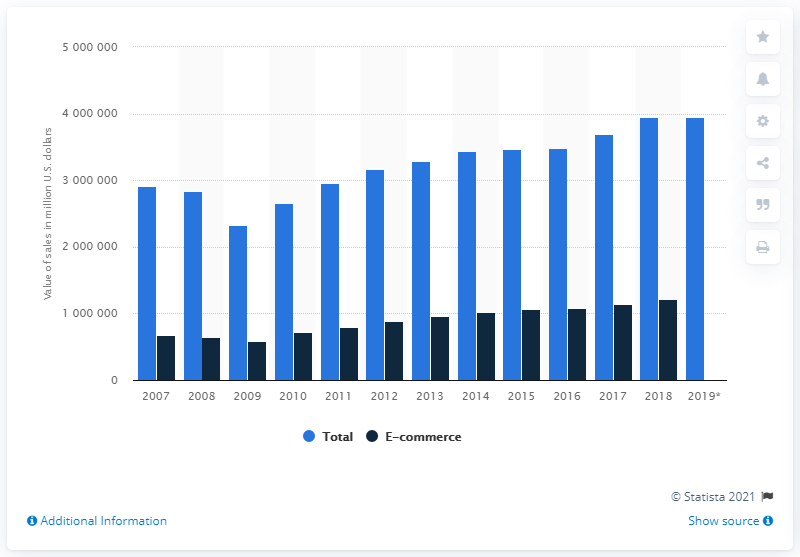Indicate a few pertinent items in this graphic. In 2018, the value of e-commerce trade for durable goods was 121,198,500. 